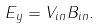<formula> <loc_0><loc_0><loc_500><loc_500>E _ { y } = V _ { i n } B _ { i n } .</formula> 